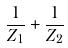<formula> <loc_0><loc_0><loc_500><loc_500>\frac { 1 } { Z _ { 1 } } + \frac { 1 } { Z _ { 2 } }</formula> 